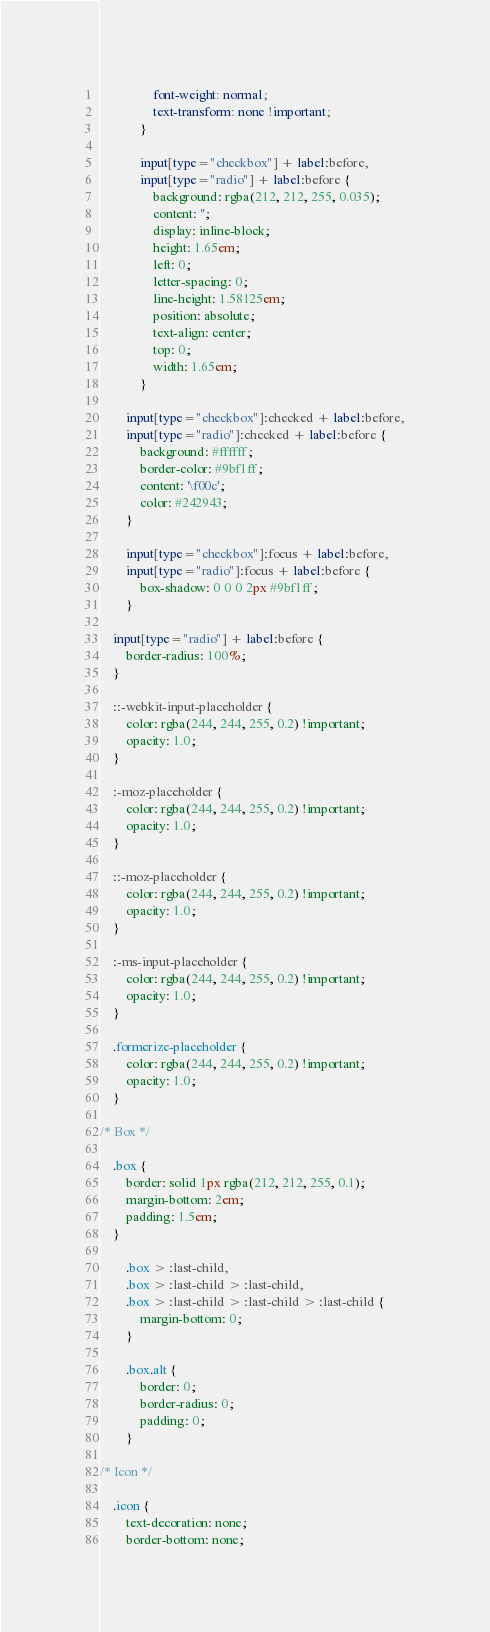<code> <loc_0><loc_0><loc_500><loc_500><_CSS_>				font-weight: normal;
				text-transform: none !important;
			}

			input[type="checkbox"] + label:before,
			input[type="radio"] + label:before {
				background: rgba(212, 212, 255, 0.035);
				content: '';
				display: inline-block;
				height: 1.65em;
				left: 0;
				letter-spacing: 0;
				line-height: 1.58125em;
				position: absolute;
				text-align: center;
				top: 0;
				width: 1.65em;
			}

		input[type="checkbox"]:checked + label:before,
		input[type="radio"]:checked + label:before {
			background: #ffffff;
			border-color: #9bf1ff;
			content: '\f00c';
			color: #242943;
		}

		input[type="checkbox"]:focus + label:before,
		input[type="radio"]:focus + label:before {
			box-shadow: 0 0 0 2px #9bf1ff;
		}

	input[type="radio"] + label:before {
		border-radius: 100%;
	}

	::-webkit-input-placeholder {
		color: rgba(244, 244, 255, 0.2) !important;
		opacity: 1.0;
	}

	:-moz-placeholder {
		color: rgba(244, 244, 255, 0.2) !important;
		opacity: 1.0;
	}

	::-moz-placeholder {
		color: rgba(244, 244, 255, 0.2) !important;
		opacity: 1.0;
	}

	:-ms-input-placeholder {
		color: rgba(244, 244, 255, 0.2) !important;
		opacity: 1.0;
	}

	.formerize-placeholder {
		color: rgba(244, 244, 255, 0.2) !important;
		opacity: 1.0;
	}

/* Box */

	.box {
		border: solid 1px rgba(212, 212, 255, 0.1);
		margin-bottom: 2em;
		padding: 1.5em;
	}

		.box > :last-child,
		.box > :last-child > :last-child,
		.box > :last-child > :last-child > :last-child {
			margin-bottom: 0;
		}

		.box.alt {
			border: 0;
			border-radius: 0;
			padding: 0;
		}

/* Icon */

	.icon {
		text-decoration: none;
		border-bottom: none;</code> 